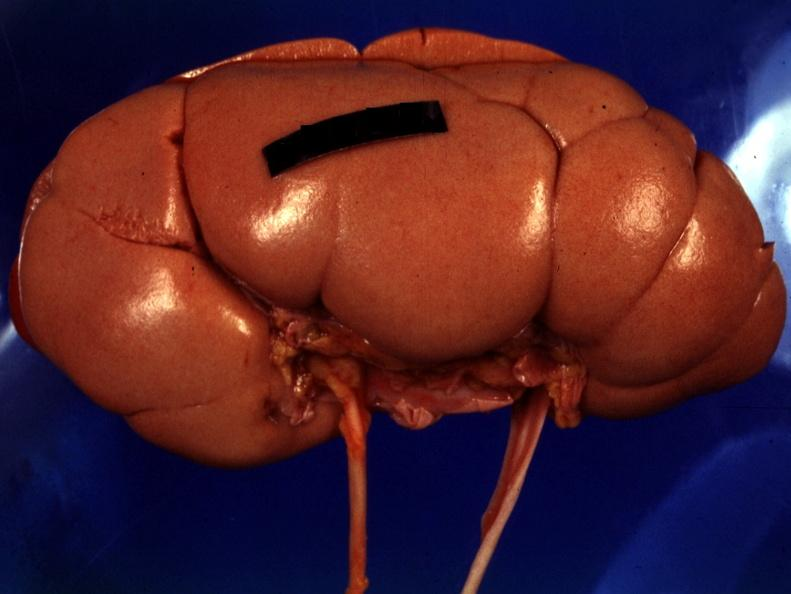s fetal lobulation present?
Answer the question using a single word or phrase. Yes 